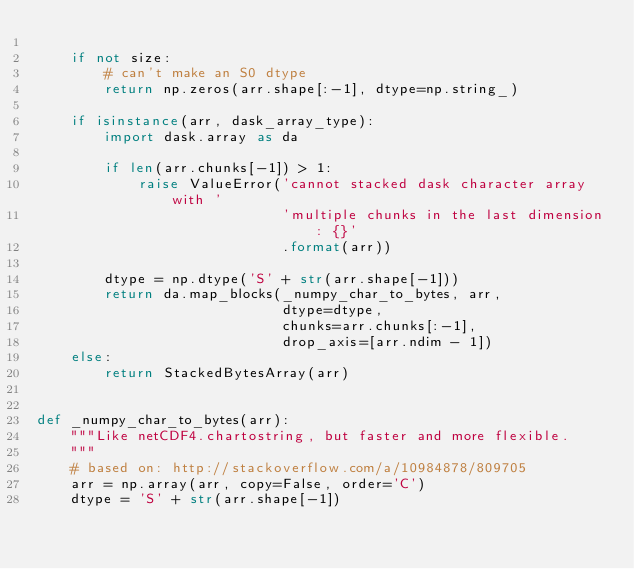<code> <loc_0><loc_0><loc_500><loc_500><_Python_>
    if not size:
        # can't make an S0 dtype
        return np.zeros(arr.shape[:-1], dtype=np.string_)

    if isinstance(arr, dask_array_type):
        import dask.array as da

        if len(arr.chunks[-1]) > 1:
            raise ValueError('cannot stacked dask character array with '
                             'multiple chunks in the last dimension: {}'
                             .format(arr))

        dtype = np.dtype('S' + str(arr.shape[-1]))
        return da.map_blocks(_numpy_char_to_bytes, arr,
                             dtype=dtype,
                             chunks=arr.chunks[:-1],
                             drop_axis=[arr.ndim - 1])
    else:
        return StackedBytesArray(arr)


def _numpy_char_to_bytes(arr):
    """Like netCDF4.chartostring, but faster and more flexible.
    """
    # based on: http://stackoverflow.com/a/10984878/809705
    arr = np.array(arr, copy=False, order='C')
    dtype = 'S' + str(arr.shape[-1])</code> 